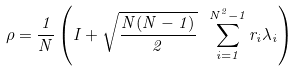Convert formula to latex. <formula><loc_0><loc_0><loc_500><loc_500>\rho = \frac { 1 } { N } \left ( I + \sqrt { \frac { N ( N - 1 ) } { 2 } } \ \sum _ { i = 1 } ^ { N ^ { 2 } - 1 } r _ { i } \lambda _ { i } \right )</formula> 